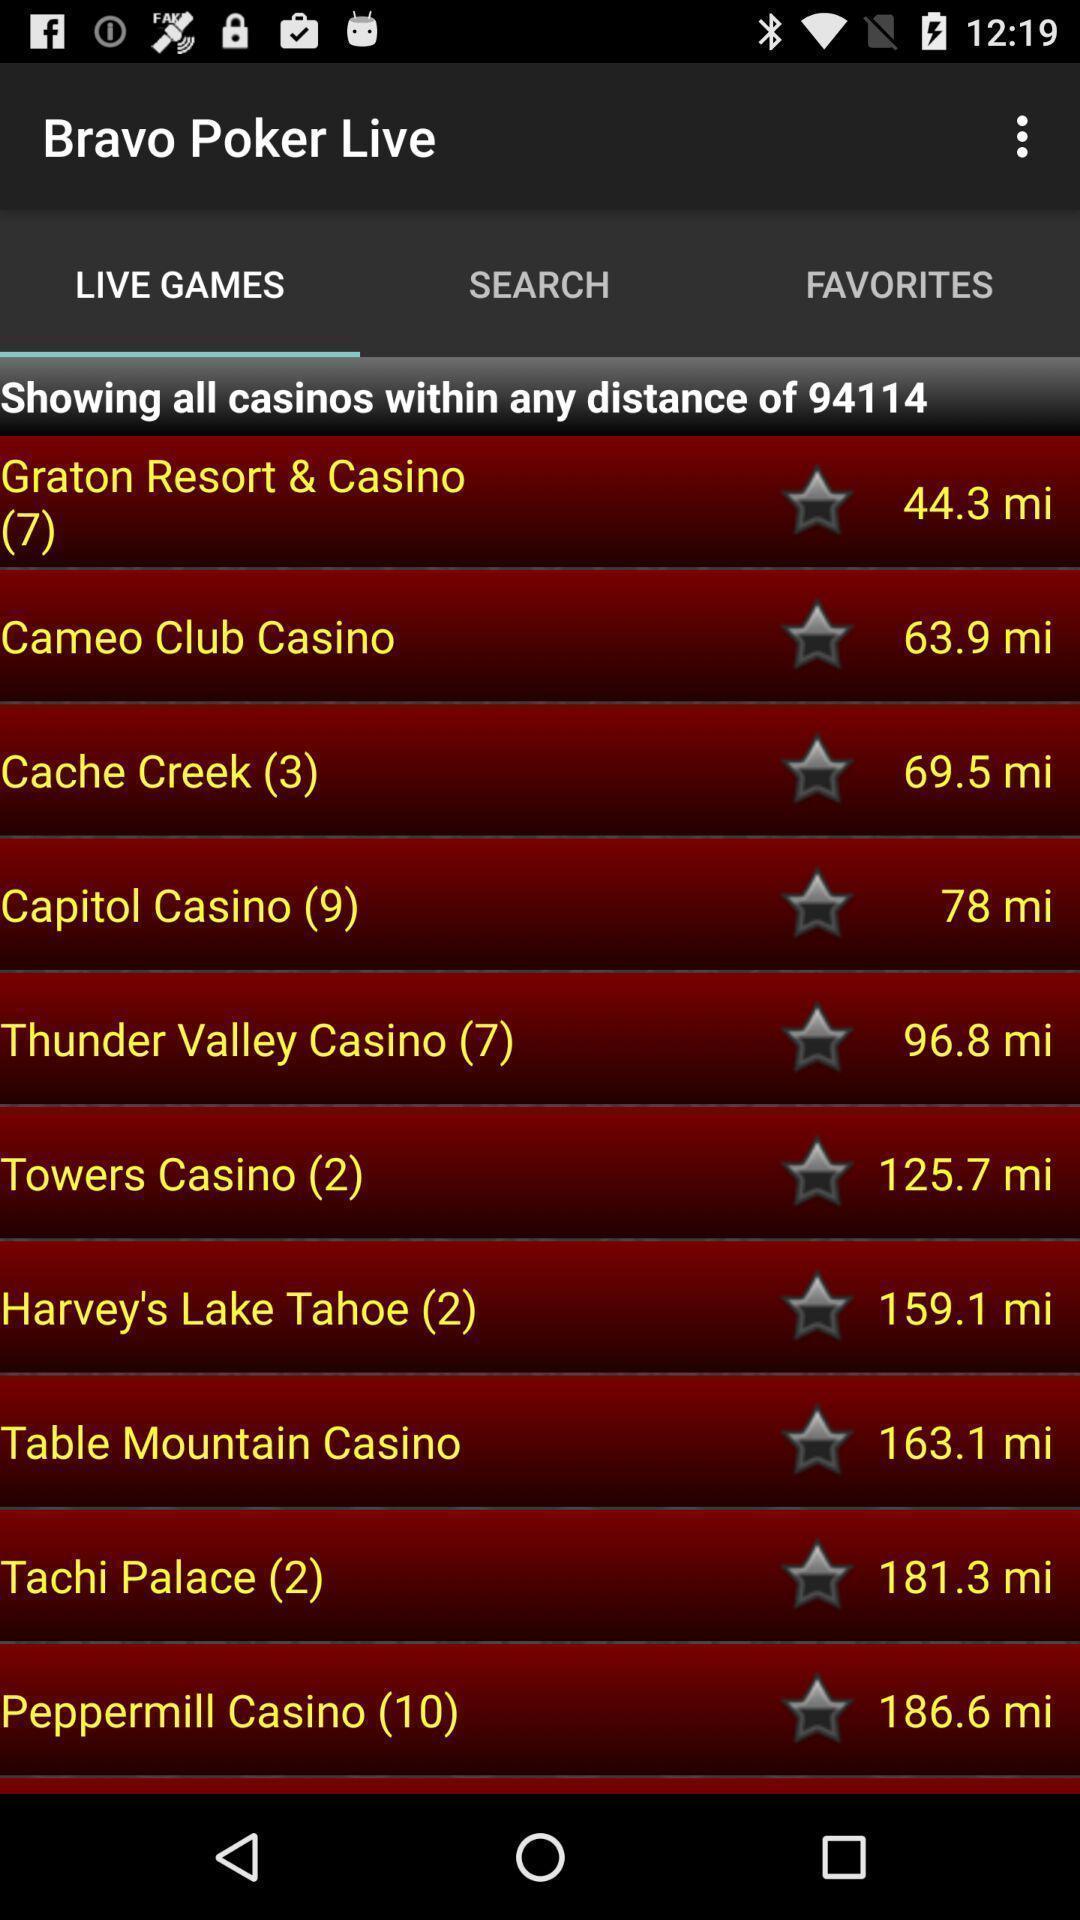Describe the content in this image. Screen displaying live games page of a games app. 